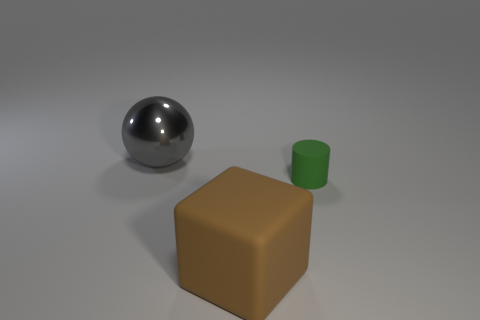The big thing behind the large object to the right of the big metal sphere is what shape?
Give a very brief answer. Sphere. Do the object in front of the cylinder and the object that is behind the green rubber cylinder have the same size?
Your answer should be very brief. Yes. Are there any spheres that have the same material as the large gray object?
Keep it short and to the point. No. There is a big thing on the right side of the big object behind the large brown object; are there any big spheres that are on the right side of it?
Ensure brevity in your answer.  No. Are there any big brown things behind the small green cylinder?
Provide a short and direct response. No. There is a big thing in front of the shiny ball; how many big gray metallic spheres are left of it?
Your answer should be compact. 1. There is a green rubber thing; is its size the same as the object on the left side of the brown thing?
Provide a short and direct response. No. Is there a cylinder of the same color as the big metallic object?
Provide a succinct answer. No. What size is the green object that is made of the same material as the big brown block?
Provide a short and direct response. Small. Is the material of the green cylinder the same as the large gray ball?
Your answer should be very brief. No. 